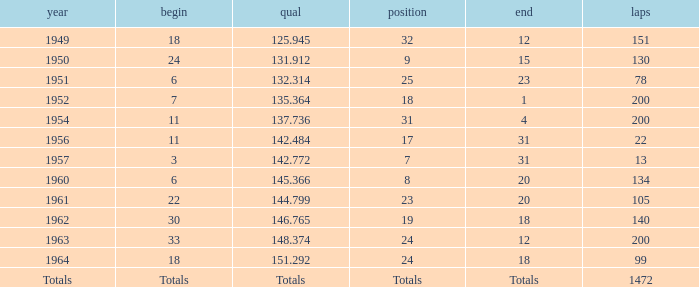Name the year for laps of 200 and rank of 24 1963.0. 